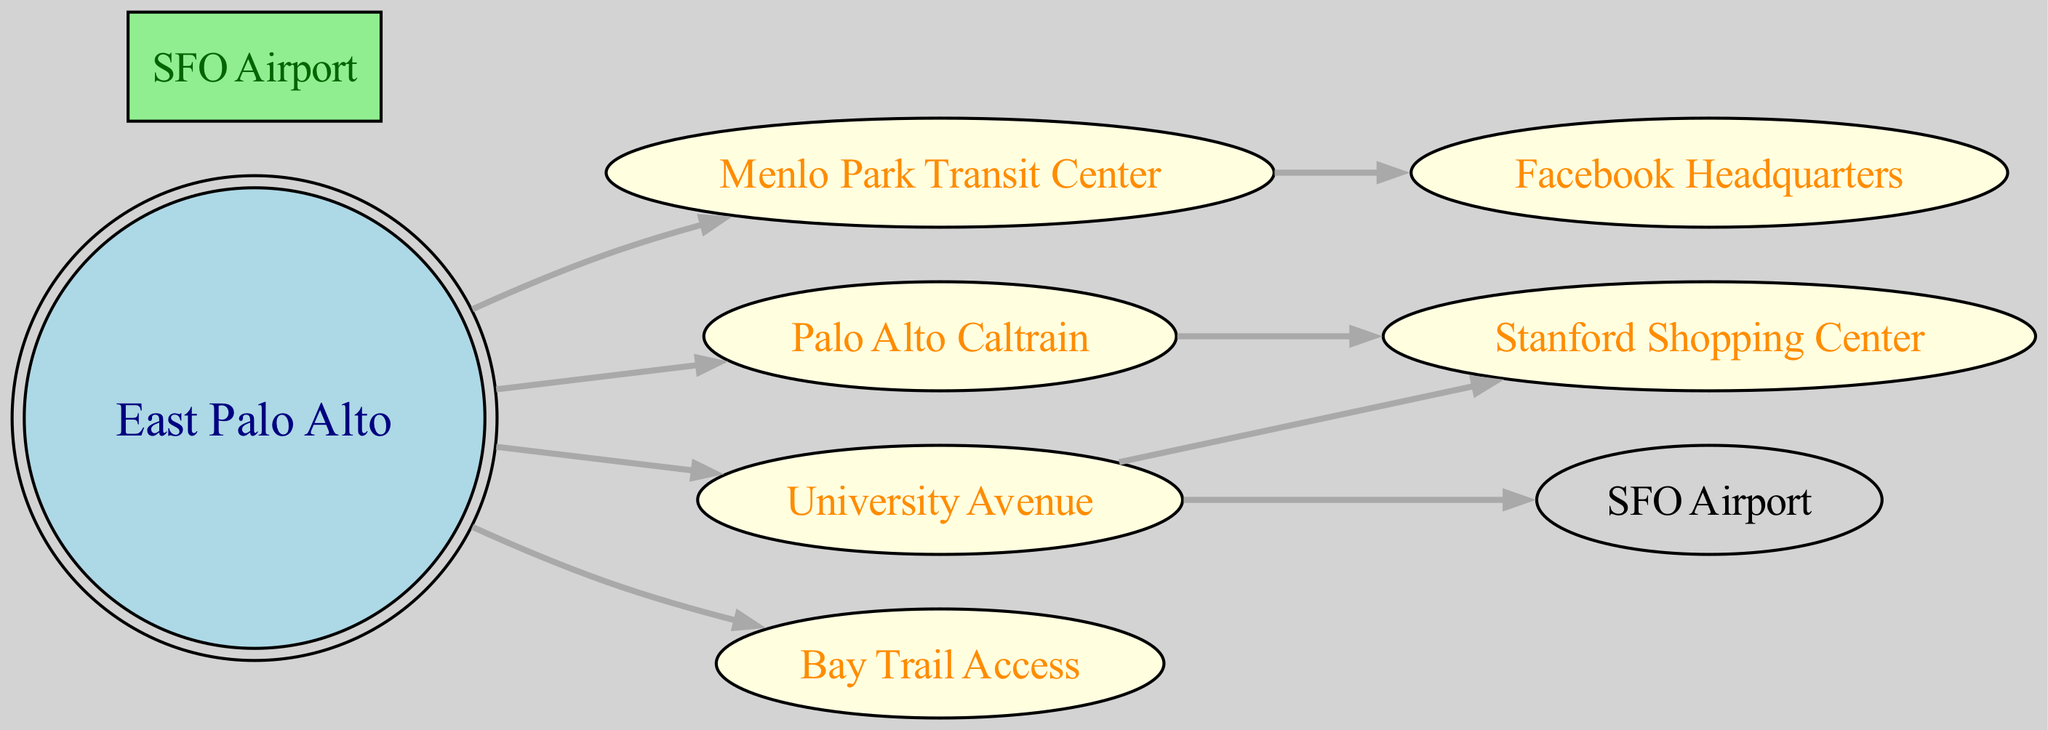What is the starting point for public transportation routes in East Palo Alto? The diagram indicates that the starting point for public transportation routes is "East Palo Alto," as it is the central node from which multiple edges originate.
Answer: East Palo Alto How many key transportation stops are indicated in the diagram? By counting the nodes listed in the diagram, there are a total of 8 key transportation stops represented.
Answer: 8 What destination can be reached directly from University Avenue? According to the diagram, University Avenue has a direct edge leading to "Stanford Shopping Center," indicating it can be reached directly.
Answer: Stanford Shopping Center Which stops are directly connected to Menlo Park Transit Center? The diagram shows that the Menlo Park Transit Center is directly connected to "Facebook Headquarters," thus indicating a direct route from there.
Answer: Facebook Headquarters What is one destination that can be reached from East Palo Alto besides Menlo Park Transit Center? The edges originating from East Palo Alto show direct connections to multiple destinations; for example, "Palo Alto Caltrain Station" can be reached directly.
Answer: Palo Alto Caltrain Station Which location serves as a connection to the airport? The edge from University Avenue to "SFO Airport" indicates that this location serves as a connection to the airport from East Palo Alto.
Answer: SFO Airport From which node can you access the Bay Trail? The diagram indicates that you can access the "Bay Trail" directly from "East Palo Alto," as there is a direct edge between these two nodes.
Answer: East Palo Alto Is there a route from Palo Alto Caltrain Station to Stanford Shopping Center? Yes, the diagram clearly shows a directed edge from "Palo Alto Caltrain Station" to "Stanford Shopping Center," confirming a route exists.
Answer: Yes How many edges are connected to East Palo Alto? By examining the diagram, we can count that there are 4 edges connected to East Palo Alto, linking it to multiple other locations.
Answer: 4 